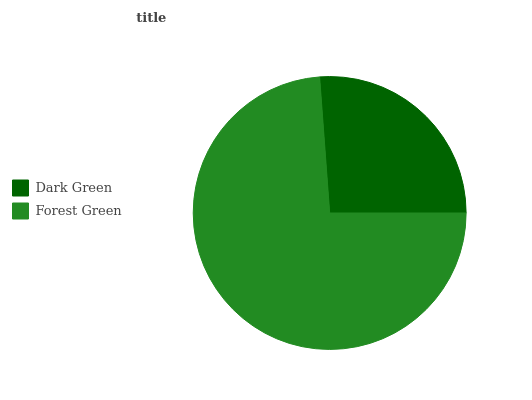Is Dark Green the minimum?
Answer yes or no. Yes. Is Forest Green the maximum?
Answer yes or no. Yes. Is Forest Green the minimum?
Answer yes or no. No. Is Forest Green greater than Dark Green?
Answer yes or no. Yes. Is Dark Green less than Forest Green?
Answer yes or no. Yes. Is Dark Green greater than Forest Green?
Answer yes or no. No. Is Forest Green less than Dark Green?
Answer yes or no. No. Is Forest Green the high median?
Answer yes or no. Yes. Is Dark Green the low median?
Answer yes or no. Yes. Is Dark Green the high median?
Answer yes or no. No. Is Forest Green the low median?
Answer yes or no. No. 